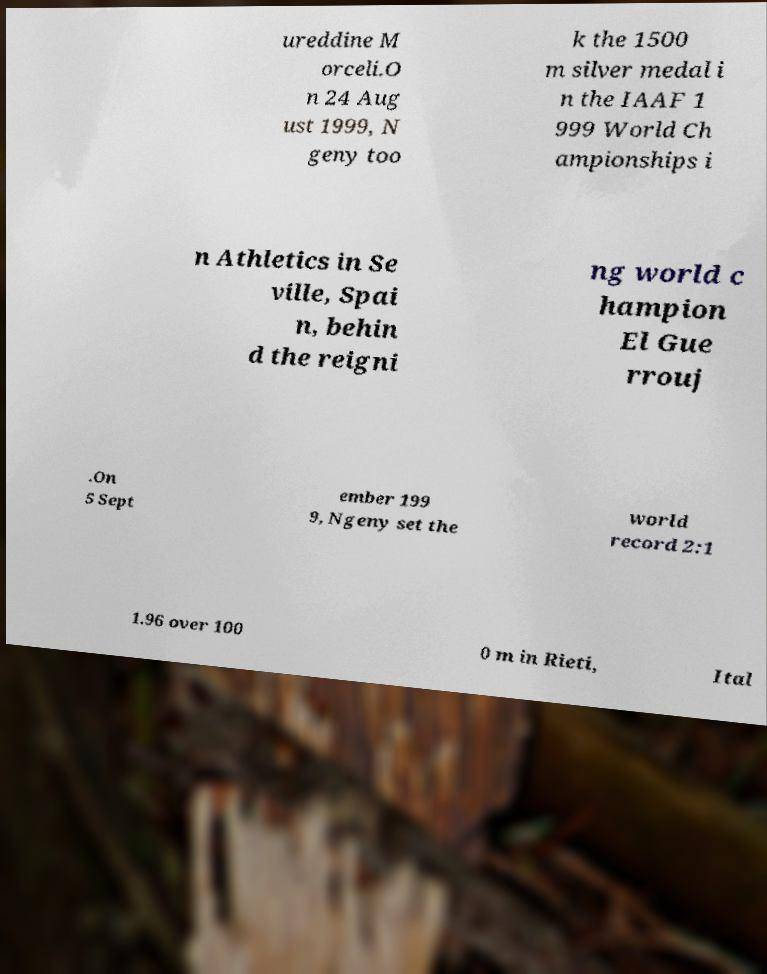Please identify and transcribe the text found in this image. ureddine M orceli.O n 24 Aug ust 1999, N geny too k the 1500 m silver medal i n the IAAF 1 999 World Ch ampionships i n Athletics in Se ville, Spai n, behin d the reigni ng world c hampion El Gue rrouj .On 5 Sept ember 199 9, Ngeny set the world record 2:1 1.96 over 100 0 m in Rieti, Ital 